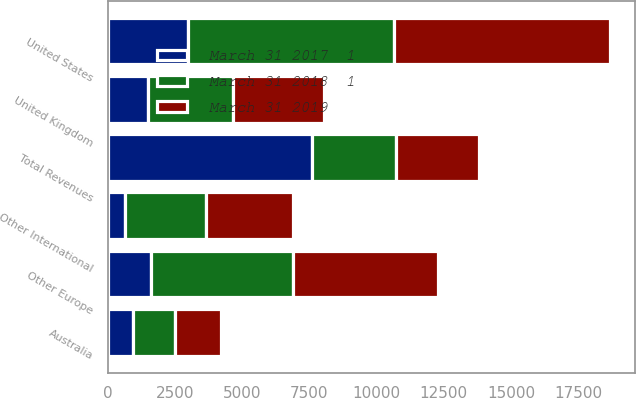Convert chart. <chart><loc_0><loc_0><loc_500><loc_500><stacked_bar_chart><ecel><fcel>United States<fcel>United Kingdom<fcel>Australia<fcel>Other Europe<fcel>Other International<fcel>Total Revenues<nl><fcel>March 31 2018  1<fcel>7677<fcel>3175<fcel>1582<fcel>5294<fcel>3025<fcel>3100<nl><fcel>March 31 2019<fcel>8015<fcel>3392<fcel>1694<fcel>5409<fcel>3223<fcel>3100<nl><fcel>March 31 2017  1<fcel>2986<fcel>1482<fcel>921<fcel>1594<fcel>624<fcel>7607<nl></chart> 